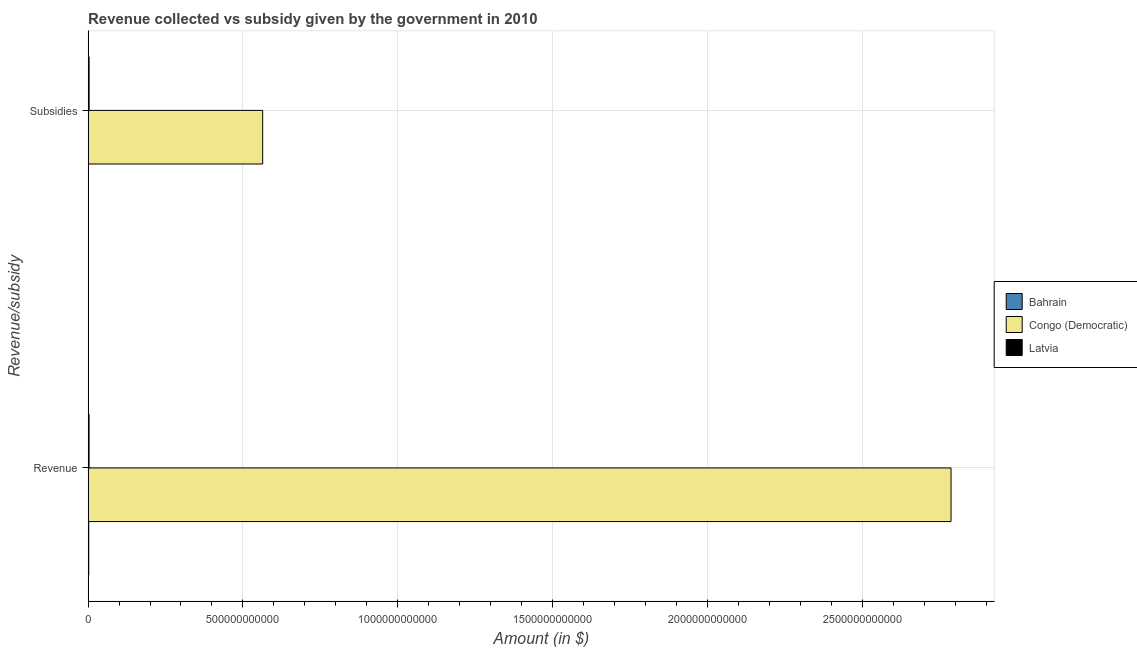How many different coloured bars are there?
Your answer should be very brief. 3. Are the number of bars on each tick of the Y-axis equal?
Offer a terse response. Yes. How many bars are there on the 1st tick from the top?
Give a very brief answer. 3. What is the label of the 1st group of bars from the top?
Give a very brief answer. Subsidies. What is the amount of revenue collected in Congo (Democratic)?
Ensure brevity in your answer.  2.79e+12. Across all countries, what is the maximum amount of subsidies given?
Keep it short and to the point. 5.64e+11. Across all countries, what is the minimum amount of revenue collected?
Ensure brevity in your answer.  2.15e+09. In which country was the amount of revenue collected maximum?
Your answer should be very brief. Congo (Democratic). In which country was the amount of subsidies given minimum?
Provide a succinct answer. Bahrain. What is the total amount of subsidies given in the graph?
Your response must be concise. 5.68e+11. What is the difference between the amount of revenue collected in Bahrain and that in Congo (Democratic)?
Provide a succinct answer. -2.78e+12. What is the difference between the amount of subsidies given in Congo (Democratic) and the amount of revenue collected in Bahrain?
Give a very brief answer. 5.62e+11. What is the average amount of revenue collected per country?
Offer a very short reply. 9.31e+11. What is the difference between the amount of subsidies given and amount of revenue collected in Congo (Democratic)?
Offer a terse response. -2.22e+12. What is the ratio of the amount of revenue collected in Congo (Democratic) to that in Bahrain?
Your answer should be compact. 1298.1. Is the amount of revenue collected in Bahrain less than that in Latvia?
Keep it short and to the point. Yes. What does the 2nd bar from the top in Revenue represents?
Your answer should be compact. Congo (Democratic). What does the 3rd bar from the bottom in Revenue represents?
Give a very brief answer. Latvia. What is the difference between two consecutive major ticks on the X-axis?
Provide a short and direct response. 5.00e+11. Are the values on the major ticks of X-axis written in scientific E-notation?
Provide a short and direct response. No. Does the graph contain grids?
Your answer should be compact. Yes. How many legend labels are there?
Your response must be concise. 3. What is the title of the graph?
Provide a succinct answer. Revenue collected vs subsidy given by the government in 2010. What is the label or title of the X-axis?
Ensure brevity in your answer.  Amount (in $). What is the label or title of the Y-axis?
Give a very brief answer. Revenue/subsidy. What is the Amount (in $) of Bahrain in Revenue?
Provide a short and direct response. 2.15e+09. What is the Amount (in $) in Congo (Democratic) in Revenue?
Keep it short and to the point. 2.79e+12. What is the Amount (in $) in Latvia in Revenue?
Give a very brief answer. 3.18e+09. What is the Amount (in $) in Bahrain in Subsidies?
Your response must be concise. 6.04e+08. What is the Amount (in $) in Congo (Democratic) in Subsidies?
Offer a terse response. 5.64e+11. What is the Amount (in $) of Latvia in Subsidies?
Offer a very short reply. 3.26e+09. Across all Revenue/subsidy, what is the maximum Amount (in $) in Bahrain?
Give a very brief answer. 2.15e+09. Across all Revenue/subsidy, what is the maximum Amount (in $) in Congo (Democratic)?
Your answer should be compact. 2.79e+12. Across all Revenue/subsidy, what is the maximum Amount (in $) in Latvia?
Make the answer very short. 3.26e+09. Across all Revenue/subsidy, what is the minimum Amount (in $) in Bahrain?
Offer a terse response. 6.04e+08. Across all Revenue/subsidy, what is the minimum Amount (in $) of Congo (Democratic)?
Keep it short and to the point. 5.64e+11. Across all Revenue/subsidy, what is the minimum Amount (in $) of Latvia?
Provide a succinct answer. 3.18e+09. What is the total Amount (in $) in Bahrain in the graph?
Keep it short and to the point. 2.75e+09. What is the total Amount (in $) of Congo (Democratic) in the graph?
Provide a succinct answer. 3.35e+12. What is the total Amount (in $) of Latvia in the graph?
Your answer should be very brief. 6.44e+09. What is the difference between the Amount (in $) in Bahrain in Revenue and that in Subsidies?
Keep it short and to the point. 1.54e+09. What is the difference between the Amount (in $) of Congo (Democratic) in Revenue and that in Subsidies?
Give a very brief answer. 2.22e+12. What is the difference between the Amount (in $) of Latvia in Revenue and that in Subsidies?
Provide a short and direct response. -7.48e+07. What is the difference between the Amount (in $) in Bahrain in Revenue and the Amount (in $) in Congo (Democratic) in Subsidies?
Provide a succinct answer. -5.62e+11. What is the difference between the Amount (in $) in Bahrain in Revenue and the Amount (in $) in Latvia in Subsidies?
Offer a terse response. -1.11e+09. What is the difference between the Amount (in $) in Congo (Democratic) in Revenue and the Amount (in $) in Latvia in Subsidies?
Offer a very short reply. 2.78e+12. What is the average Amount (in $) in Bahrain per Revenue/subsidy?
Offer a terse response. 1.38e+09. What is the average Amount (in $) of Congo (Democratic) per Revenue/subsidy?
Your answer should be compact. 1.68e+12. What is the average Amount (in $) in Latvia per Revenue/subsidy?
Keep it short and to the point. 3.22e+09. What is the difference between the Amount (in $) in Bahrain and Amount (in $) in Congo (Democratic) in Revenue?
Provide a short and direct response. -2.78e+12. What is the difference between the Amount (in $) in Bahrain and Amount (in $) in Latvia in Revenue?
Your response must be concise. -1.04e+09. What is the difference between the Amount (in $) in Congo (Democratic) and Amount (in $) in Latvia in Revenue?
Offer a terse response. 2.78e+12. What is the difference between the Amount (in $) of Bahrain and Amount (in $) of Congo (Democratic) in Subsidies?
Your response must be concise. -5.63e+11. What is the difference between the Amount (in $) in Bahrain and Amount (in $) in Latvia in Subsidies?
Ensure brevity in your answer.  -2.65e+09. What is the difference between the Amount (in $) of Congo (Democratic) and Amount (in $) of Latvia in Subsidies?
Give a very brief answer. 5.61e+11. What is the ratio of the Amount (in $) in Bahrain in Revenue to that in Subsidies?
Your answer should be compact. 3.55. What is the ratio of the Amount (in $) of Congo (Democratic) in Revenue to that in Subsidies?
Provide a succinct answer. 4.94. What is the ratio of the Amount (in $) of Latvia in Revenue to that in Subsidies?
Your answer should be very brief. 0.98. What is the difference between the highest and the second highest Amount (in $) of Bahrain?
Give a very brief answer. 1.54e+09. What is the difference between the highest and the second highest Amount (in $) in Congo (Democratic)?
Offer a terse response. 2.22e+12. What is the difference between the highest and the second highest Amount (in $) of Latvia?
Ensure brevity in your answer.  7.48e+07. What is the difference between the highest and the lowest Amount (in $) in Bahrain?
Ensure brevity in your answer.  1.54e+09. What is the difference between the highest and the lowest Amount (in $) of Congo (Democratic)?
Provide a short and direct response. 2.22e+12. What is the difference between the highest and the lowest Amount (in $) of Latvia?
Provide a short and direct response. 7.48e+07. 